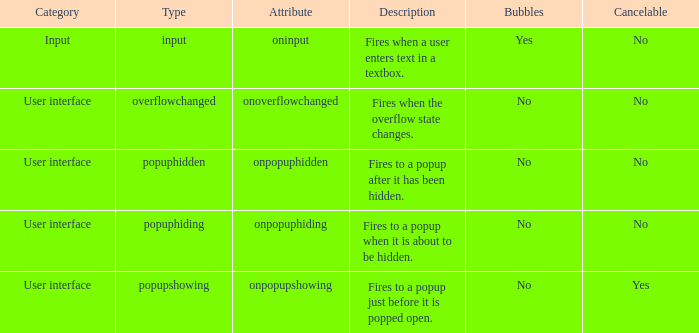What's the cancelable with bubbles being yes No. 